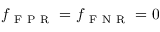Convert formula to latex. <formula><loc_0><loc_0><loc_500><loc_500>f _ { F P R } = f _ { F N R } = 0</formula> 